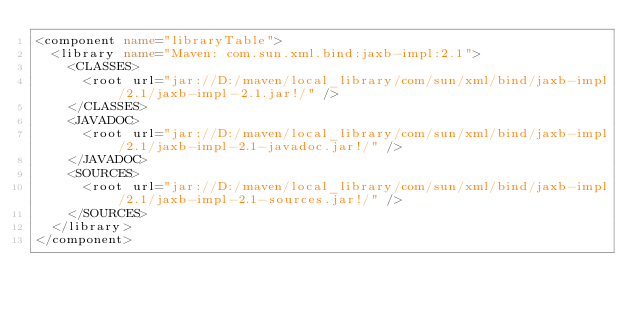<code> <loc_0><loc_0><loc_500><loc_500><_XML_><component name="libraryTable">
  <library name="Maven: com.sun.xml.bind:jaxb-impl:2.1">
    <CLASSES>
      <root url="jar://D:/maven/local_library/com/sun/xml/bind/jaxb-impl/2.1/jaxb-impl-2.1.jar!/" />
    </CLASSES>
    <JAVADOC>
      <root url="jar://D:/maven/local_library/com/sun/xml/bind/jaxb-impl/2.1/jaxb-impl-2.1-javadoc.jar!/" />
    </JAVADOC>
    <SOURCES>
      <root url="jar://D:/maven/local_library/com/sun/xml/bind/jaxb-impl/2.1/jaxb-impl-2.1-sources.jar!/" />
    </SOURCES>
  </library>
</component></code> 